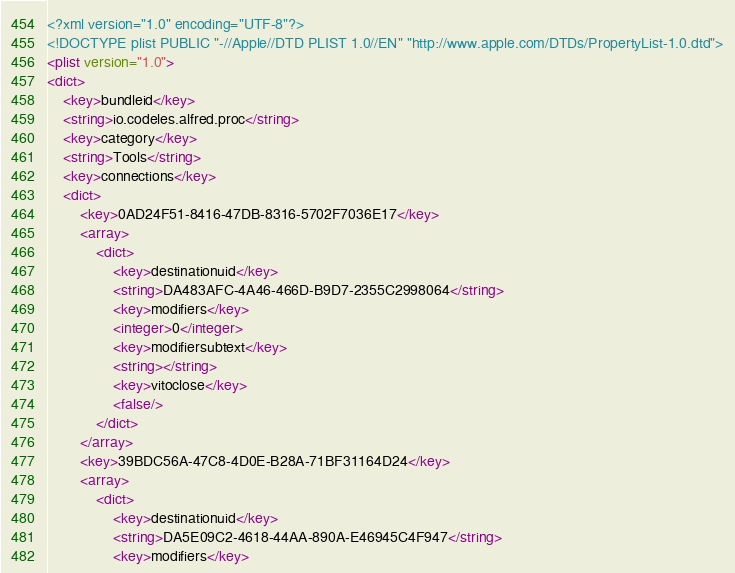<code> <loc_0><loc_0><loc_500><loc_500><_XML_><?xml version="1.0" encoding="UTF-8"?>
<!DOCTYPE plist PUBLIC "-//Apple//DTD PLIST 1.0//EN" "http://www.apple.com/DTDs/PropertyList-1.0.dtd">
<plist version="1.0">
<dict>
	<key>bundleid</key>
	<string>io.codeles.alfred.proc</string>
	<key>category</key>
	<string>Tools</string>
	<key>connections</key>
	<dict>
		<key>0AD24F51-8416-47DB-8316-5702F7036E17</key>
		<array>
			<dict>
				<key>destinationuid</key>
				<string>DA483AFC-4A46-466D-B9D7-2355C2998064</string>
				<key>modifiers</key>
				<integer>0</integer>
				<key>modifiersubtext</key>
				<string></string>
				<key>vitoclose</key>
				<false/>
			</dict>
		</array>
		<key>39BDC56A-47C8-4D0E-B28A-71BF31164D24</key>
		<array>
			<dict>
				<key>destinationuid</key>
				<string>DA5E09C2-4618-44AA-890A-E46945C4F947</string>
				<key>modifiers</key></code> 